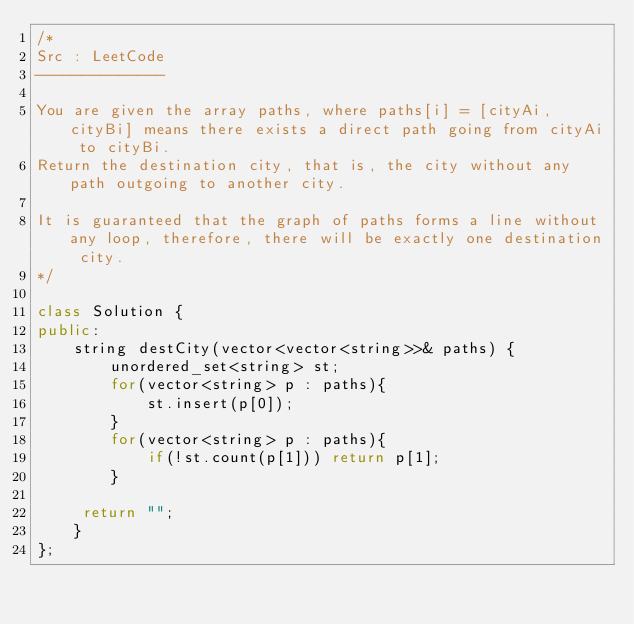Convert code to text. <code><loc_0><loc_0><loc_500><loc_500><_C++_>/*
Src : LeetCode
--------------

You are given the array paths, where paths[i] = [cityAi, cityBi] means there exists a direct path going from cityAi to cityBi. 
Return the destination city, that is, the city without any path outgoing to another city.

It is guaranteed that the graph of paths forms a line without any loop, therefore, there will be exactly one destination city.
*/

class Solution {
public:
    string destCity(vector<vector<string>>& paths) {
        unordered_set<string> st;
        for(vector<string> p : paths){
            st.insert(p[0]);
        }
        for(vector<string> p : paths){
            if(!st.count(p[1])) return p[1];
        }
        
     return "";    
    }
};</code> 